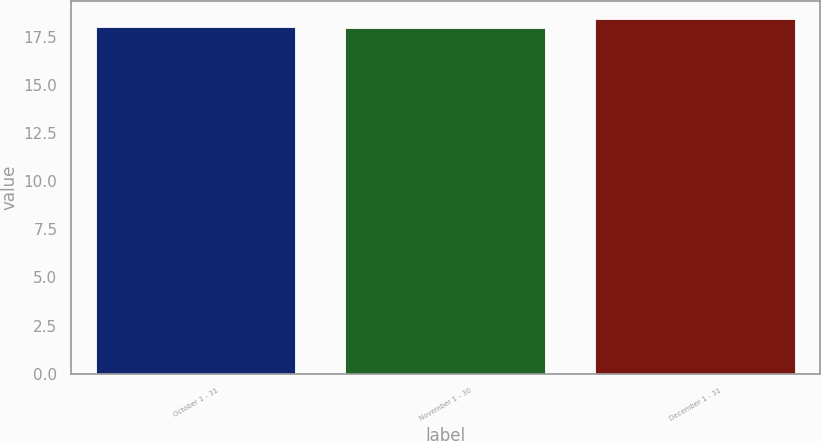Convert chart to OTSL. <chart><loc_0><loc_0><loc_500><loc_500><bar_chart><fcel>October 1 - 31<fcel>November 1 - 30<fcel>December 1 - 31<nl><fcel>18.01<fcel>17.96<fcel>18.43<nl></chart> 